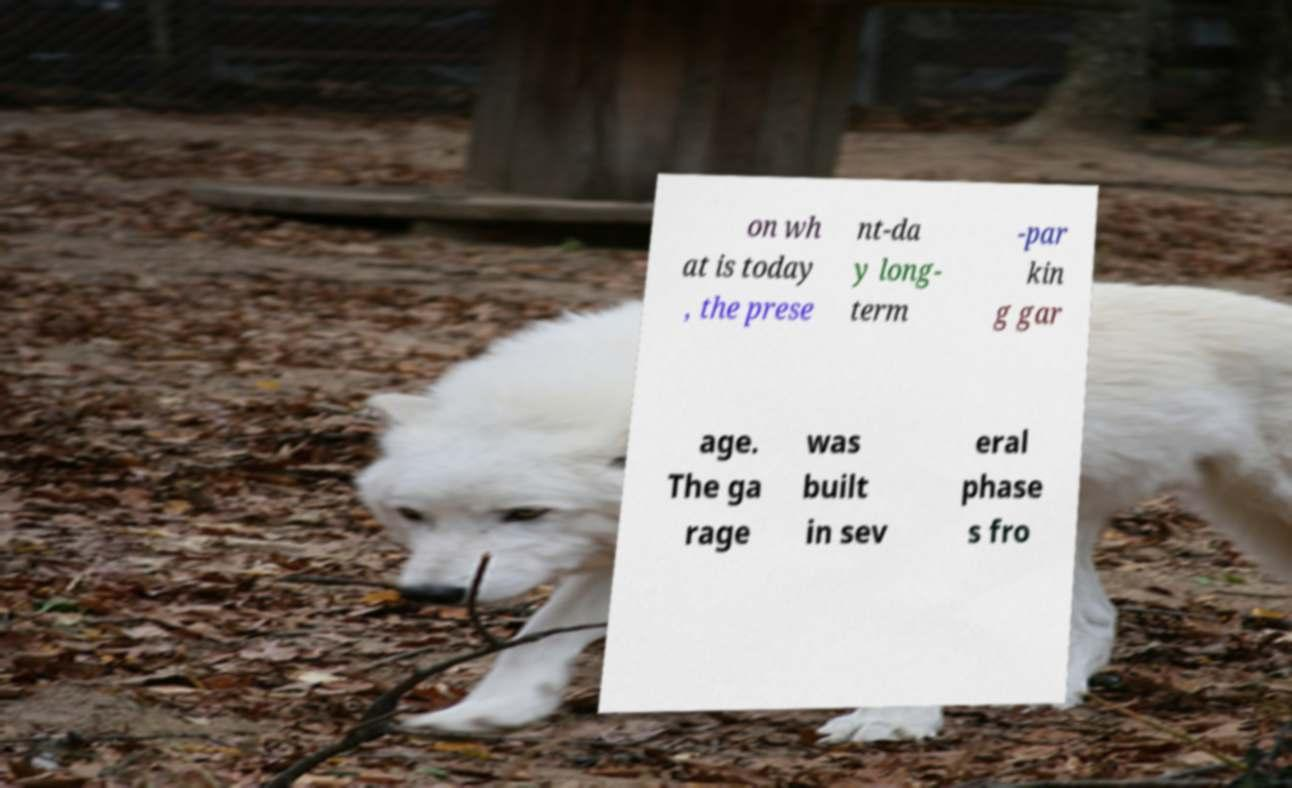For documentation purposes, I need the text within this image transcribed. Could you provide that? on wh at is today , the prese nt-da y long- term -par kin g gar age. The ga rage was built in sev eral phase s fro 